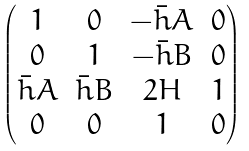<formula> <loc_0><loc_0><loc_500><loc_500>\begin{pmatrix} 1 & 0 & - \bar { h } A & 0 \\ 0 & 1 & - \bar { h } B & 0 \\ \bar { h } A & \bar { h } B & 2 H & 1 \\ 0 & 0 & 1 & 0 \end{pmatrix}</formula> 